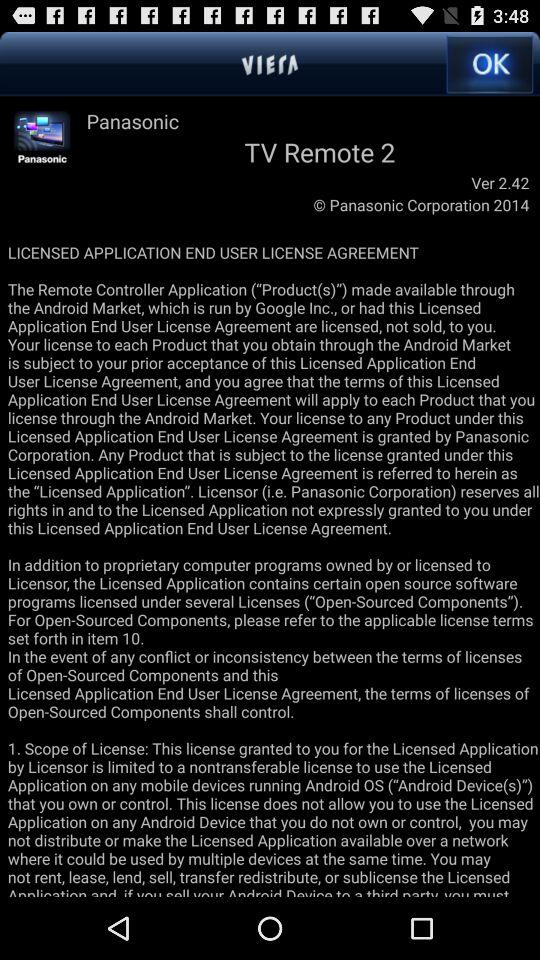What is the version number? The version number is 2.42. 